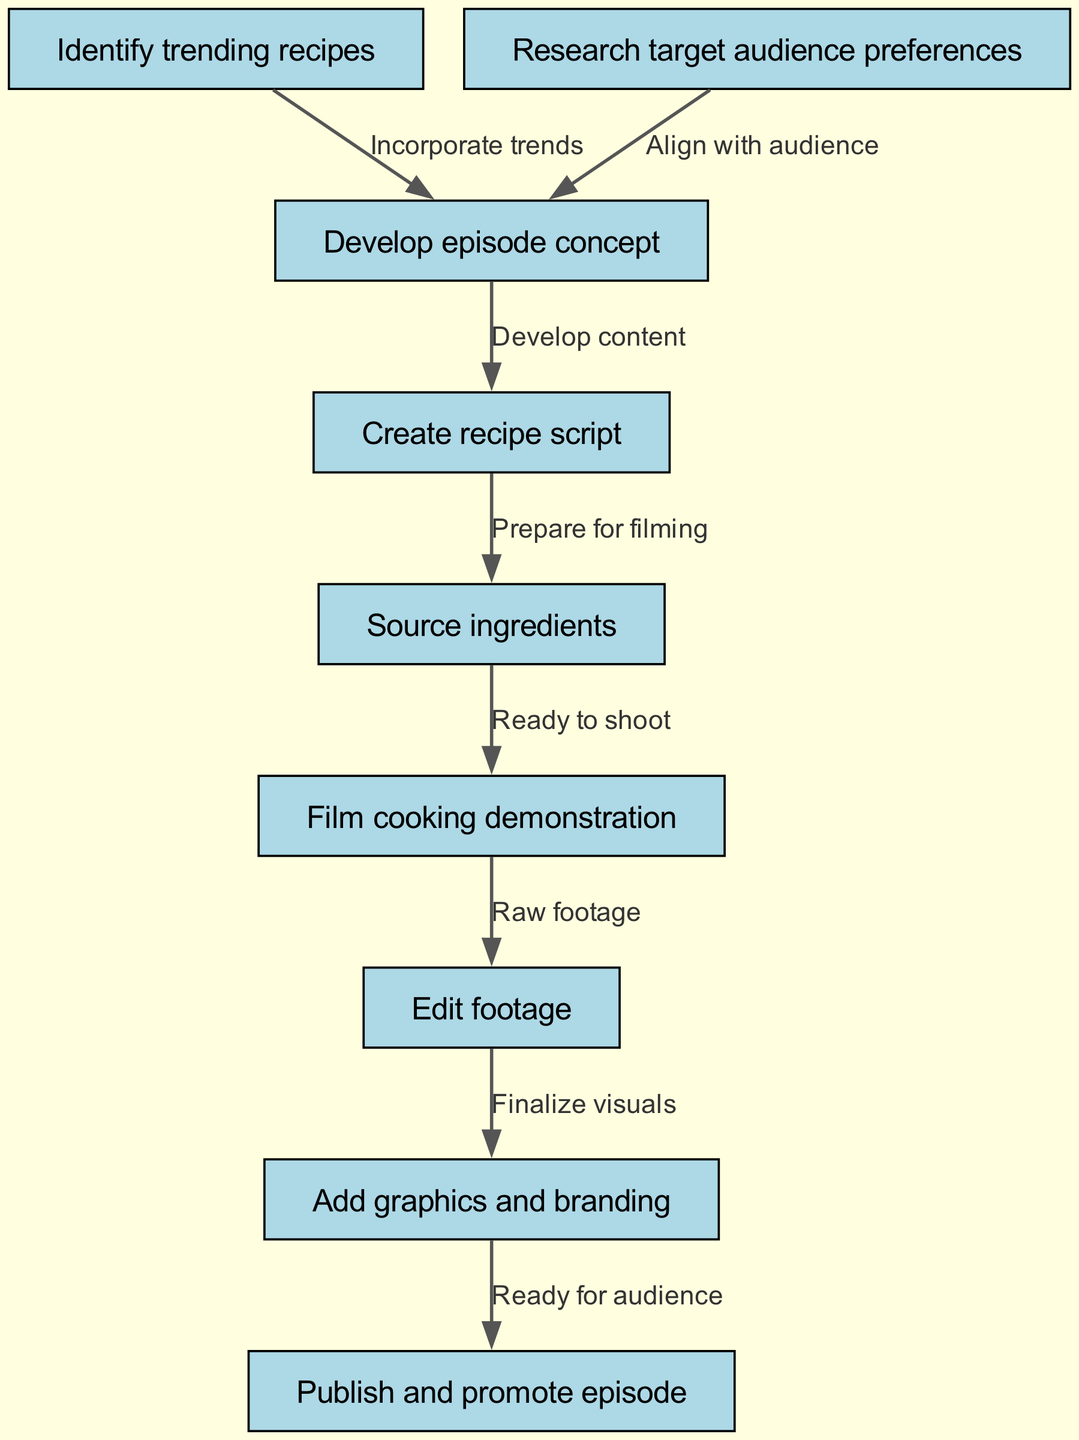What is the first step in the content creation process? The first step listed in the diagram is "Identify trending recipes". This is indicated as the top node in the flow chart.
Answer: Identify trending recipes How many nodes are present in the diagram? There are a total of nine nodes in the diagram, each representing different steps in the content creation process. This can be counted directly from the nodes list.
Answer: Nine Which nodes are linked to "Develop episode concept"? The "Develop episode concept" node is linked to two preceding nodes: "Identify trending recipes" and "Research target audience preferences". Both these nodes point towards developing an episode concept based on trends and audience preferences.
Answer: Identify trending recipes, Research target audience preferences What does the edge from "Edit footage" to "Add graphics and branding" represent? The edge from "Edit footage" to "Add graphics and branding" represents the finalization of visuals after raw footage has been edited. This shows the sequential process where editing is a prerequisite for adding graphics.
Answer: Finalize visuals What is the last step before publishing and promoting the episode? The last step before publishing and promoting the episode is "Add graphics and branding". This indicates that all graphics and branding must be completed before the episode is shared with the audience.
Answer: Add graphics and branding What does the edge from "Create recipe script" to "Source ingredients" signify? This edge signifies that once the recipe script is created, the next step is to source ingredients for the cooking demonstration. It shows a progression of tasks needed for preparation.
Answer: Prepare for filming How many edges are there in the diagram? There are eight edges in the diagram, each showing a connection between two nodes that details the flow of the content creation process. This can be counted directly from the edges list.
Answer: Eight Which node is the final step in the process? The final step in the process is "Publish and promote episode". This is the endpoint in the flow where the created content is shared with the audience.
Answer: Publish and promote episode 